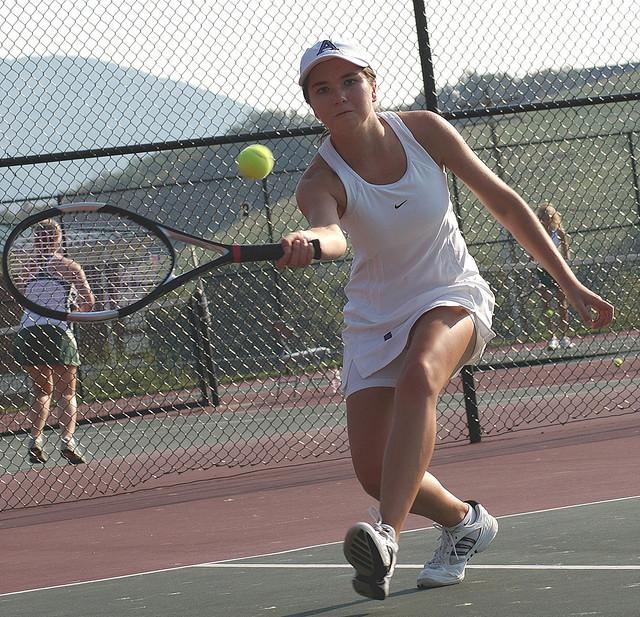Is she going to hit the ball?
Keep it brief. Yes. What color is the woman's shirt?
Keep it brief. White. What sport is the woman playing?
Write a very short answer. Tennis. 